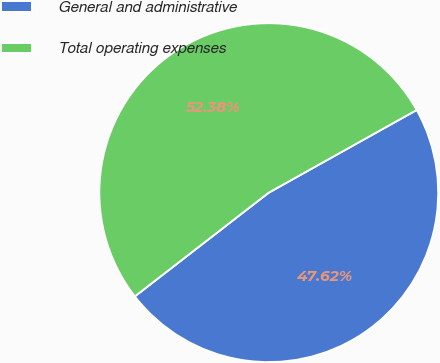Convert chart to OTSL. <chart><loc_0><loc_0><loc_500><loc_500><pie_chart><fcel>General and administrative<fcel>Total operating expenses<nl><fcel>47.62%<fcel>52.38%<nl></chart> 